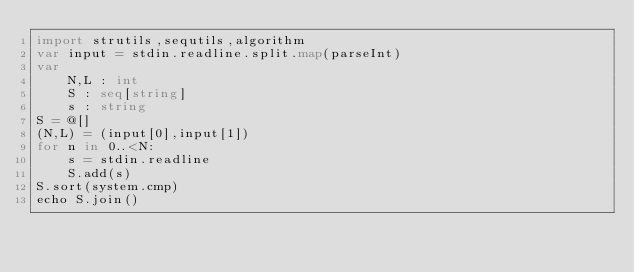<code> <loc_0><loc_0><loc_500><loc_500><_Nim_>import strutils,sequtils,algorithm
var input = stdin.readline.split.map(parseInt)
var 
    N,L : int
    S : seq[string]
    s : string
S = @[]
(N,L) = (input[0],input[1])
for n in 0..<N:
    s = stdin.readline
    S.add(s)
S.sort(system.cmp)
echo S.join()</code> 